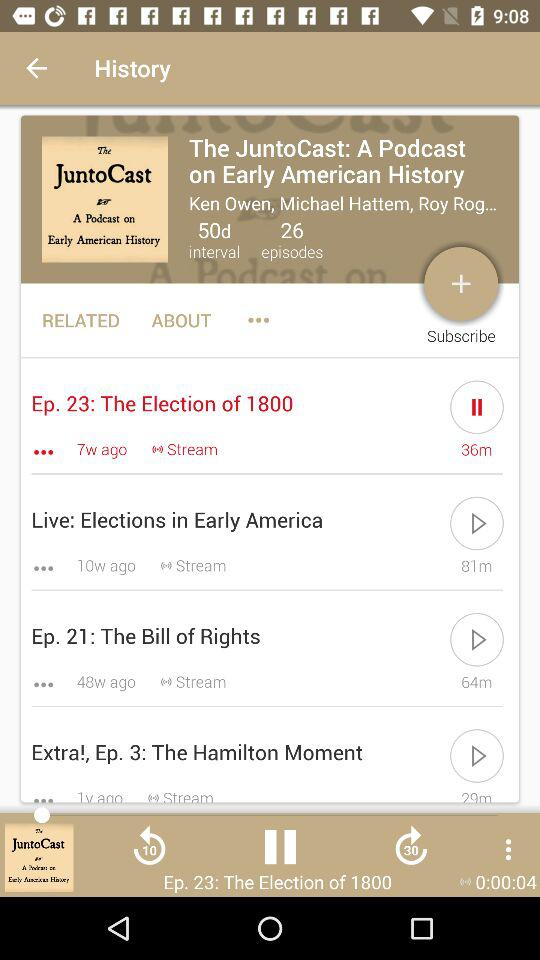Which audio is playing? The audio that is playing is " The Election of 1800". 